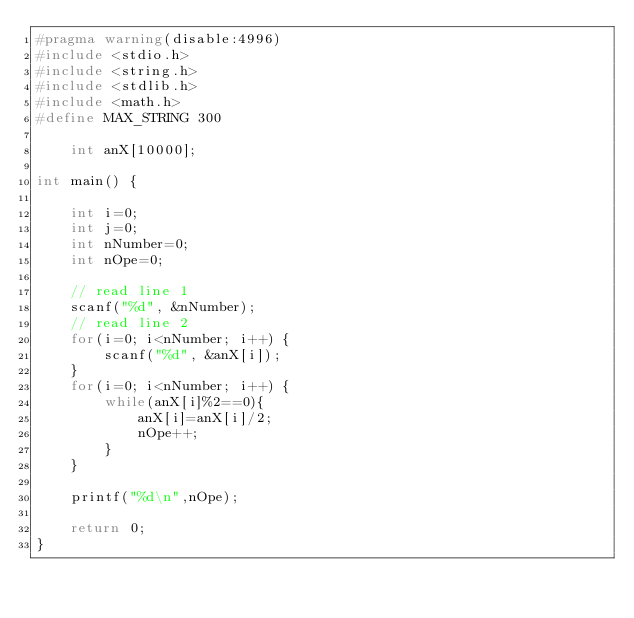<code> <loc_0><loc_0><loc_500><loc_500><_C_>#pragma warning(disable:4996)
#include <stdio.h>
#include <string.h>
#include <stdlib.h>
#include <math.h>
#define MAX_STRING 300

	int anX[10000];

int main() {

	int i=0;
	int j=0;
	int nNumber=0;
	int nOpe=0;

	// read line 1
    scanf("%d", &nNumber);
	// read line 2
	for(i=0; i<nNumber; i++) {
        scanf("%d", &anX[i]);
	}
	for(i=0; i<nNumber; i++) {
        while(anX[i]%2==0){
			anX[i]=anX[i]/2;
			nOpe++;
		}
	}

	printf("%d\n",nOpe);

    return 0;
}

</code> 